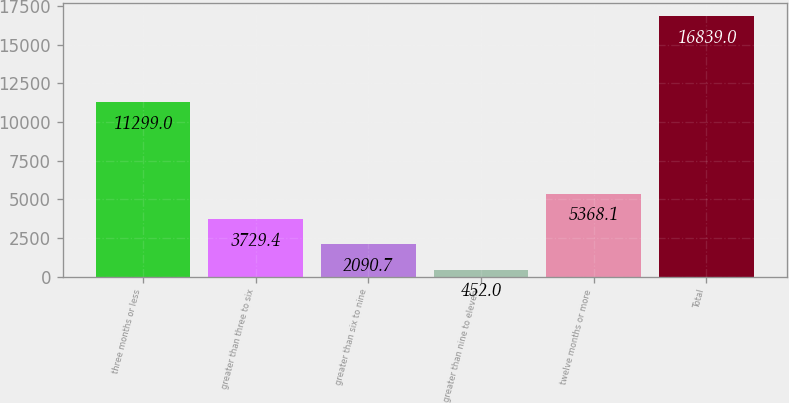Convert chart to OTSL. <chart><loc_0><loc_0><loc_500><loc_500><bar_chart><fcel>three months or less<fcel>greater than three to six<fcel>greater than six to nine<fcel>greater than nine to eleven<fcel>twelve months or more<fcel>Total<nl><fcel>11299<fcel>3729.4<fcel>2090.7<fcel>452<fcel>5368.1<fcel>16839<nl></chart> 